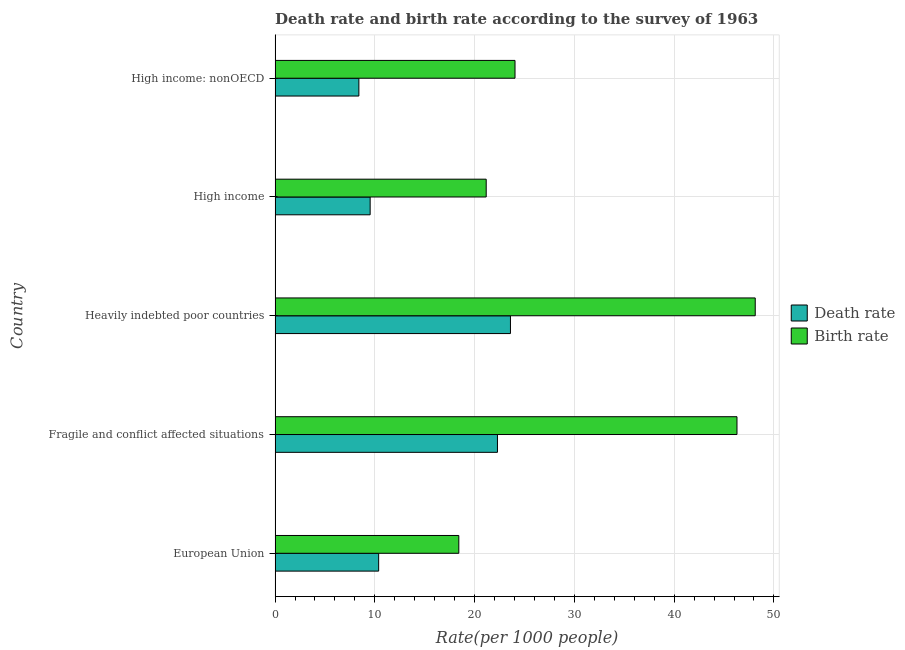Are the number of bars on each tick of the Y-axis equal?
Ensure brevity in your answer.  Yes. What is the label of the 4th group of bars from the top?
Give a very brief answer. Fragile and conflict affected situations. What is the death rate in High income: nonOECD?
Provide a succinct answer. 8.4. Across all countries, what is the maximum birth rate?
Offer a very short reply. 48.13. Across all countries, what is the minimum birth rate?
Offer a very short reply. 18.42. In which country was the death rate maximum?
Provide a short and direct response. Heavily indebted poor countries. In which country was the death rate minimum?
Your answer should be compact. High income: nonOECD. What is the total birth rate in the graph?
Offer a very short reply. 158.05. What is the difference between the death rate in European Union and that in Fragile and conflict affected situations?
Your answer should be very brief. -11.91. What is the difference between the death rate in High income: nonOECD and the birth rate in Fragile and conflict affected situations?
Offer a very short reply. -37.9. What is the average birth rate per country?
Offer a very short reply. 31.61. What is the difference between the death rate and birth rate in High income: nonOECD?
Give a very brief answer. -15.65. What is the ratio of the death rate in Fragile and conflict affected situations to that in High income?
Your response must be concise. 2.34. What is the difference between the highest and the second highest death rate?
Keep it short and to the point. 1.3. What is the difference between the highest and the lowest death rate?
Offer a terse response. 15.19. Is the sum of the birth rate in Fragile and conflict affected situations and High income: nonOECD greater than the maximum death rate across all countries?
Offer a terse response. Yes. What does the 2nd bar from the top in High income: nonOECD represents?
Your answer should be compact. Death rate. What does the 2nd bar from the bottom in High income represents?
Give a very brief answer. Birth rate. Are all the bars in the graph horizontal?
Your response must be concise. Yes. How many countries are there in the graph?
Your answer should be compact. 5. What is the difference between two consecutive major ticks on the X-axis?
Keep it short and to the point. 10. Are the values on the major ticks of X-axis written in scientific E-notation?
Your answer should be compact. No. Does the graph contain any zero values?
Keep it short and to the point. No. How many legend labels are there?
Provide a succinct answer. 2. How are the legend labels stacked?
Ensure brevity in your answer.  Vertical. What is the title of the graph?
Make the answer very short. Death rate and birth rate according to the survey of 1963. What is the label or title of the X-axis?
Offer a very short reply. Rate(per 1000 people). What is the label or title of the Y-axis?
Offer a very short reply. Country. What is the Rate(per 1000 people) in Death rate in European Union?
Keep it short and to the point. 10.38. What is the Rate(per 1000 people) in Birth rate in European Union?
Give a very brief answer. 18.42. What is the Rate(per 1000 people) of Death rate in Fragile and conflict affected situations?
Keep it short and to the point. 22.29. What is the Rate(per 1000 people) in Birth rate in Fragile and conflict affected situations?
Keep it short and to the point. 46.3. What is the Rate(per 1000 people) in Death rate in Heavily indebted poor countries?
Keep it short and to the point. 23.59. What is the Rate(per 1000 people) of Birth rate in Heavily indebted poor countries?
Offer a terse response. 48.13. What is the Rate(per 1000 people) in Death rate in High income?
Your answer should be compact. 9.53. What is the Rate(per 1000 people) of Birth rate in High income?
Ensure brevity in your answer.  21.16. What is the Rate(per 1000 people) of Death rate in High income: nonOECD?
Offer a very short reply. 8.4. What is the Rate(per 1000 people) in Birth rate in High income: nonOECD?
Offer a very short reply. 24.05. Across all countries, what is the maximum Rate(per 1000 people) of Death rate?
Offer a terse response. 23.59. Across all countries, what is the maximum Rate(per 1000 people) in Birth rate?
Make the answer very short. 48.13. Across all countries, what is the minimum Rate(per 1000 people) of Death rate?
Your answer should be very brief. 8.4. Across all countries, what is the minimum Rate(per 1000 people) in Birth rate?
Keep it short and to the point. 18.42. What is the total Rate(per 1000 people) in Death rate in the graph?
Provide a short and direct response. 74.19. What is the total Rate(per 1000 people) of Birth rate in the graph?
Make the answer very short. 158.05. What is the difference between the Rate(per 1000 people) in Death rate in European Union and that in Fragile and conflict affected situations?
Your response must be concise. -11.91. What is the difference between the Rate(per 1000 people) of Birth rate in European Union and that in Fragile and conflict affected situations?
Make the answer very short. -27.88. What is the difference between the Rate(per 1000 people) in Death rate in European Union and that in Heavily indebted poor countries?
Offer a very short reply. -13.21. What is the difference between the Rate(per 1000 people) of Birth rate in European Union and that in Heavily indebted poor countries?
Provide a short and direct response. -29.71. What is the difference between the Rate(per 1000 people) of Death rate in European Union and that in High income?
Offer a terse response. 0.85. What is the difference between the Rate(per 1000 people) of Birth rate in European Union and that in High income?
Provide a short and direct response. -2.75. What is the difference between the Rate(per 1000 people) of Death rate in European Union and that in High income: nonOECD?
Make the answer very short. 1.98. What is the difference between the Rate(per 1000 people) in Birth rate in European Union and that in High income: nonOECD?
Give a very brief answer. -5.63. What is the difference between the Rate(per 1000 people) in Death rate in Fragile and conflict affected situations and that in Heavily indebted poor countries?
Provide a short and direct response. -1.3. What is the difference between the Rate(per 1000 people) in Birth rate in Fragile and conflict affected situations and that in Heavily indebted poor countries?
Provide a short and direct response. -1.83. What is the difference between the Rate(per 1000 people) in Death rate in Fragile and conflict affected situations and that in High income?
Provide a succinct answer. 12.76. What is the difference between the Rate(per 1000 people) of Birth rate in Fragile and conflict affected situations and that in High income?
Give a very brief answer. 25.14. What is the difference between the Rate(per 1000 people) in Death rate in Fragile and conflict affected situations and that in High income: nonOECD?
Give a very brief answer. 13.89. What is the difference between the Rate(per 1000 people) in Birth rate in Fragile and conflict affected situations and that in High income: nonOECD?
Provide a short and direct response. 22.25. What is the difference between the Rate(per 1000 people) of Death rate in Heavily indebted poor countries and that in High income?
Give a very brief answer. 14.06. What is the difference between the Rate(per 1000 people) of Birth rate in Heavily indebted poor countries and that in High income?
Provide a short and direct response. 26.96. What is the difference between the Rate(per 1000 people) of Death rate in Heavily indebted poor countries and that in High income: nonOECD?
Offer a terse response. 15.19. What is the difference between the Rate(per 1000 people) in Birth rate in Heavily indebted poor countries and that in High income: nonOECD?
Ensure brevity in your answer.  24.08. What is the difference between the Rate(per 1000 people) in Death rate in High income and that in High income: nonOECD?
Give a very brief answer. 1.13. What is the difference between the Rate(per 1000 people) of Birth rate in High income and that in High income: nonOECD?
Keep it short and to the point. -2.89. What is the difference between the Rate(per 1000 people) in Death rate in European Union and the Rate(per 1000 people) in Birth rate in Fragile and conflict affected situations?
Your answer should be very brief. -35.92. What is the difference between the Rate(per 1000 people) of Death rate in European Union and the Rate(per 1000 people) of Birth rate in Heavily indebted poor countries?
Provide a short and direct response. -37.75. What is the difference between the Rate(per 1000 people) in Death rate in European Union and the Rate(per 1000 people) in Birth rate in High income?
Ensure brevity in your answer.  -10.78. What is the difference between the Rate(per 1000 people) in Death rate in European Union and the Rate(per 1000 people) in Birth rate in High income: nonOECD?
Your answer should be compact. -13.67. What is the difference between the Rate(per 1000 people) of Death rate in Fragile and conflict affected situations and the Rate(per 1000 people) of Birth rate in Heavily indebted poor countries?
Offer a very short reply. -25.84. What is the difference between the Rate(per 1000 people) of Death rate in Fragile and conflict affected situations and the Rate(per 1000 people) of Birth rate in High income?
Your response must be concise. 1.13. What is the difference between the Rate(per 1000 people) in Death rate in Fragile and conflict affected situations and the Rate(per 1000 people) in Birth rate in High income: nonOECD?
Provide a short and direct response. -1.76. What is the difference between the Rate(per 1000 people) of Death rate in Heavily indebted poor countries and the Rate(per 1000 people) of Birth rate in High income?
Keep it short and to the point. 2.43. What is the difference between the Rate(per 1000 people) of Death rate in Heavily indebted poor countries and the Rate(per 1000 people) of Birth rate in High income: nonOECD?
Make the answer very short. -0.46. What is the difference between the Rate(per 1000 people) in Death rate in High income and the Rate(per 1000 people) in Birth rate in High income: nonOECD?
Offer a terse response. -14.52. What is the average Rate(per 1000 people) of Death rate per country?
Your answer should be very brief. 14.84. What is the average Rate(per 1000 people) of Birth rate per country?
Your answer should be very brief. 31.61. What is the difference between the Rate(per 1000 people) of Death rate and Rate(per 1000 people) of Birth rate in European Union?
Make the answer very short. -8.03. What is the difference between the Rate(per 1000 people) in Death rate and Rate(per 1000 people) in Birth rate in Fragile and conflict affected situations?
Offer a very short reply. -24.01. What is the difference between the Rate(per 1000 people) in Death rate and Rate(per 1000 people) in Birth rate in Heavily indebted poor countries?
Give a very brief answer. -24.53. What is the difference between the Rate(per 1000 people) in Death rate and Rate(per 1000 people) in Birth rate in High income?
Offer a very short reply. -11.63. What is the difference between the Rate(per 1000 people) in Death rate and Rate(per 1000 people) in Birth rate in High income: nonOECD?
Your response must be concise. -15.65. What is the ratio of the Rate(per 1000 people) of Death rate in European Union to that in Fragile and conflict affected situations?
Offer a very short reply. 0.47. What is the ratio of the Rate(per 1000 people) of Birth rate in European Union to that in Fragile and conflict affected situations?
Your answer should be compact. 0.4. What is the ratio of the Rate(per 1000 people) of Death rate in European Union to that in Heavily indebted poor countries?
Give a very brief answer. 0.44. What is the ratio of the Rate(per 1000 people) in Birth rate in European Union to that in Heavily indebted poor countries?
Offer a very short reply. 0.38. What is the ratio of the Rate(per 1000 people) of Death rate in European Union to that in High income?
Offer a terse response. 1.09. What is the ratio of the Rate(per 1000 people) in Birth rate in European Union to that in High income?
Provide a short and direct response. 0.87. What is the ratio of the Rate(per 1000 people) in Death rate in European Union to that in High income: nonOECD?
Give a very brief answer. 1.24. What is the ratio of the Rate(per 1000 people) in Birth rate in European Union to that in High income: nonOECD?
Provide a short and direct response. 0.77. What is the ratio of the Rate(per 1000 people) of Death rate in Fragile and conflict affected situations to that in Heavily indebted poor countries?
Make the answer very short. 0.94. What is the ratio of the Rate(per 1000 people) in Birth rate in Fragile and conflict affected situations to that in Heavily indebted poor countries?
Give a very brief answer. 0.96. What is the ratio of the Rate(per 1000 people) in Death rate in Fragile and conflict affected situations to that in High income?
Keep it short and to the point. 2.34. What is the ratio of the Rate(per 1000 people) in Birth rate in Fragile and conflict affected situations to that in High income?
Your answer should be compact. 2.19. What is the ratio of the Rate(per 1000 people) of Death rate in Fragile and conflict affected situations to that in High income: nonOECD?
Provide a succinct answer. 2.65. What is the ratio of the Rate(per 1000 people) in Birth rate in Fragile and conflict affected situations to that in High income: nonOECD?
Offer a terse response. 1.93. What is the ratio of the Rate(per 1000 people) of Death rate in Heavily indebted poor countries to that in High income?
Your answer should be compact. 2.48. What is the ratio of the Rate(per 1000 people) of Birth rate in Heavily indebted poor countries to that in High income?
Your response must be concise. 2.27. What is the ratio of the Rate(per 1000 people) in Death rate in Heavily indebted poor countries to that in High income: nonOECD?
Offer a terse response. 2.81. What is the ratio of the Rate(per 1000 people) of Birth rate in Heavily indebted poor countries to that in High income: nonOECD?
Offer a very short reply. 2. What is the ratio of the Rate(per 1000 people) of Death rate in High income to that in High income: nonOECD?
Your response must be concise. 1.13. What is the ratio of the Rate(per 1000 people) in Birth rate in High income to that in High income: nonOECD?
Ensure brevity in your answer.  0.88. What is the difference between the highest and the second highest Rate(per 1000 people) of Death rate?
Make the answer very short. 1.3. What is the difference between the highest and the second highest Rate(per 1000 people) in Birth rate?
Give a very brief answer. 1.83. What is the difference between the highest and the lowest Rate(per 1000 people) in Death rate?
Offer a terse response. 15.19. What is the difference between the highest and the lowest Rate(per 1000 people) in Birth rate?
Keep it short and to the point. 29.71. 